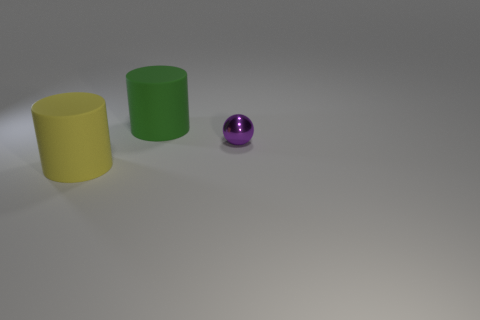Add 1 small yellow things. How many objects exist? 4 Subtract all spheres. How many objects are left? 2 Subtract all small blue matte balls. Subtract all purple metal balls. How many objects are left? 2 Add 1 small balls. How many small balls are left? 2 Add 2 blue things. How many blue things exist? 2 Subtract 1 purple balls. How many objects are left? 2 